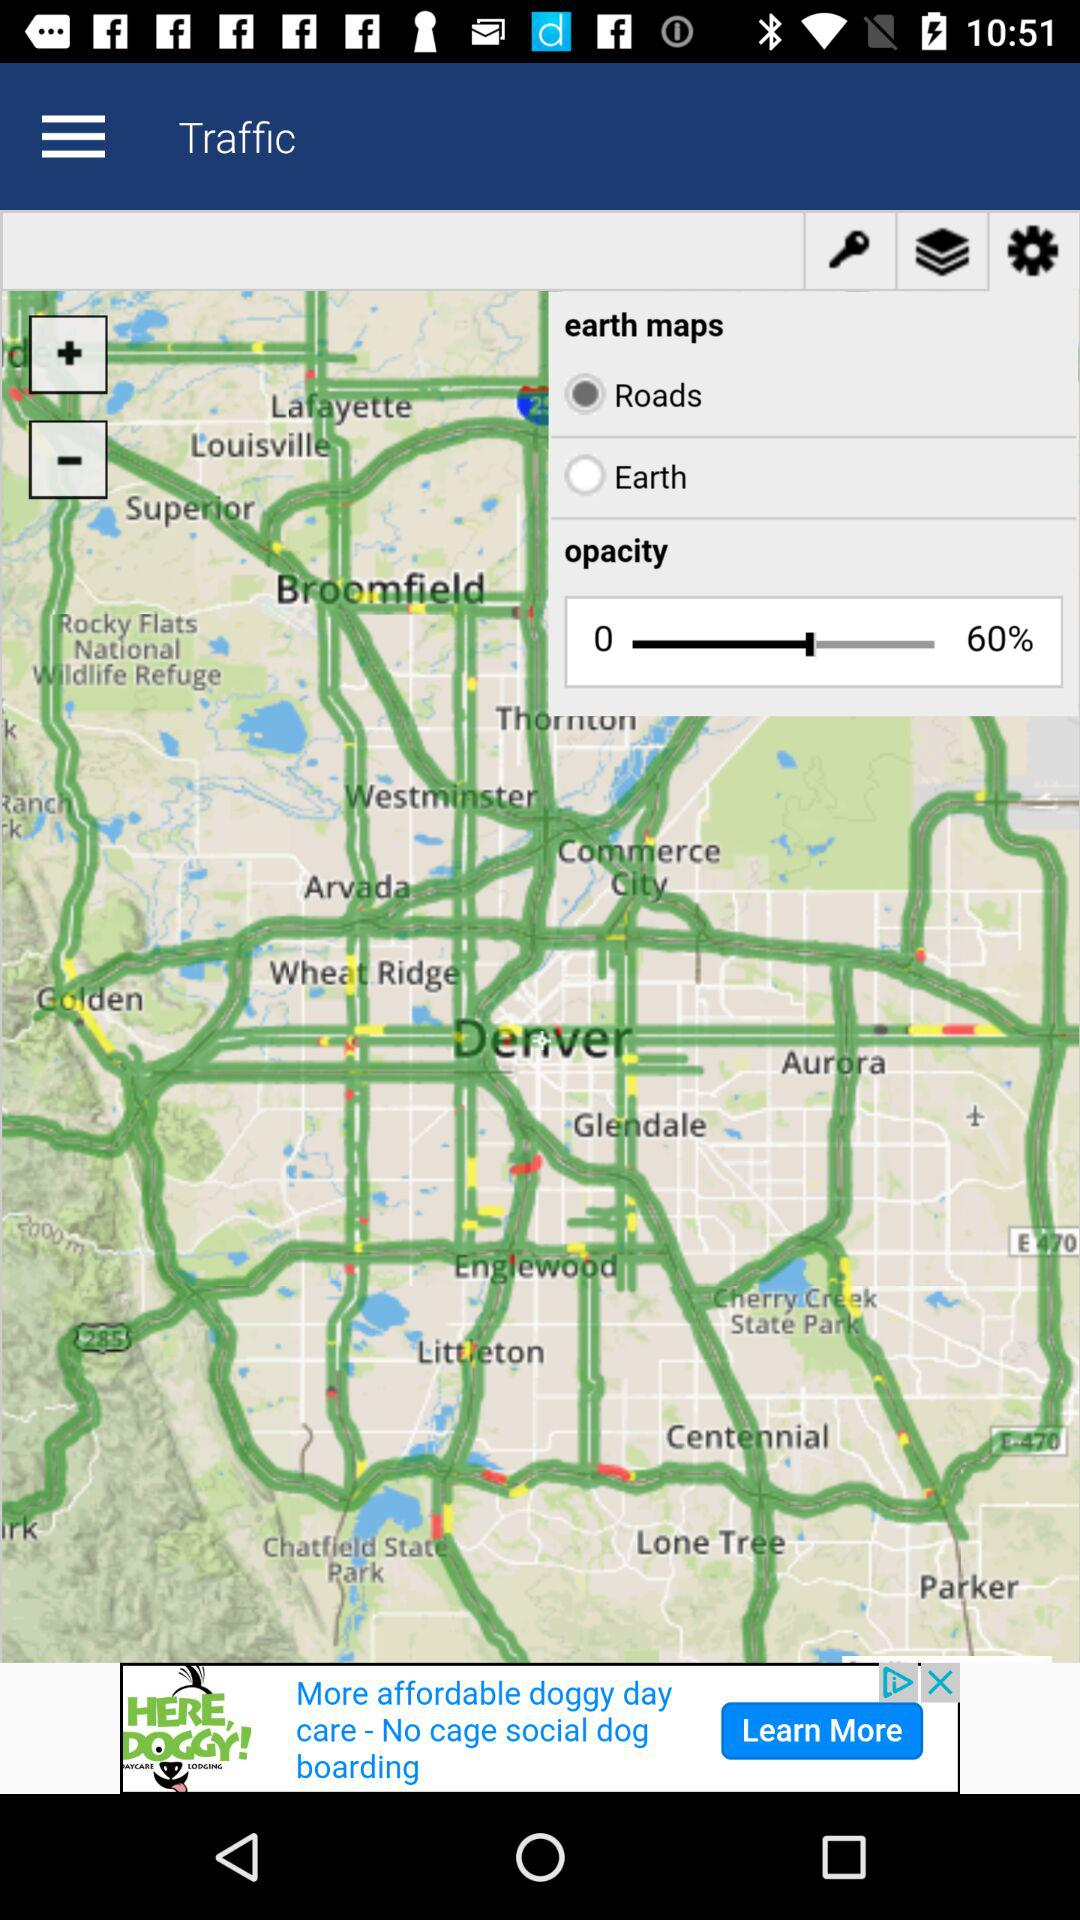Is "Roads" selected or not?
Answer the question using a single word or phrase. It is selected. 